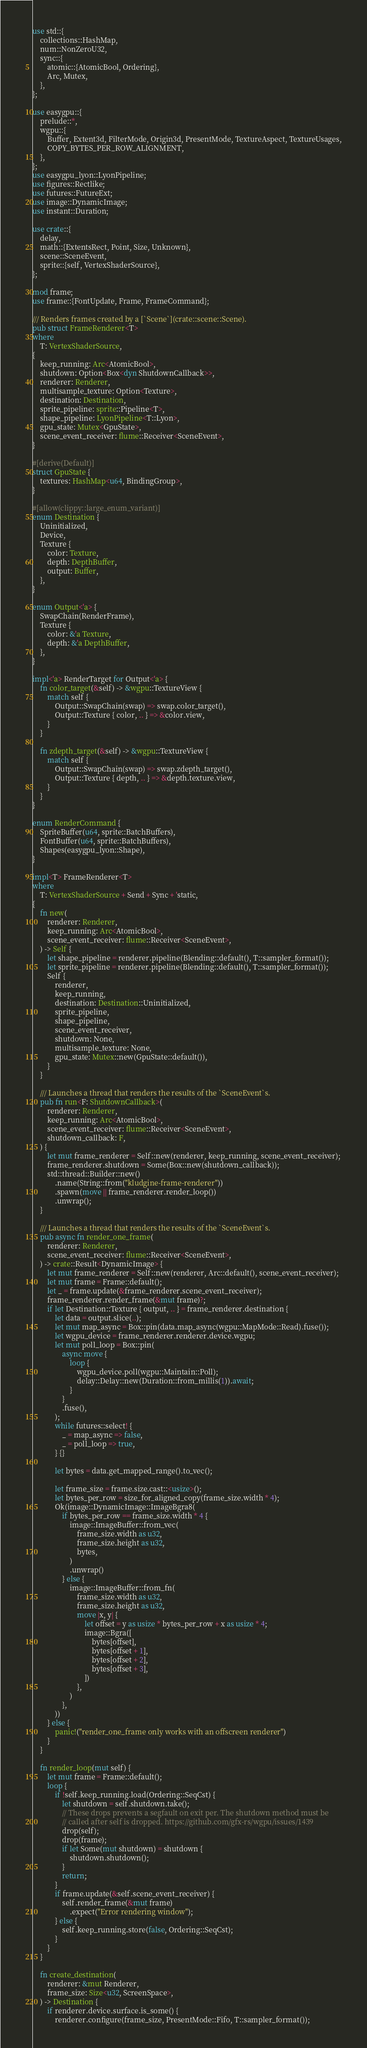<code> <loc_0><loc_0><loc_500><loc_500><_Rust_>use std::{
    collections::HashMap,
    num::NonZeroU32,
    sync::{
        atomic::{AtomicBool, Ordering},
        Arc, Mutex,
    },
};

use easygpu::{
    prelude::*,
    wgpu::{
        Buffer, Extent3d, FilterMode, Origin3d, PresentMode, TextureAspect, TextureUsages,
        COPY_BYTES_PER_ROW_ALIGNMENT,
    },
};
use easygpu_lyon::LyonPipeline;
use figures::Rectlike;
use futures::FutureExt;
use image::DynamicImage;
use instant::Duration;

use crate::{
    delay,
    math::{ExtentsRect, Point, Size, Unknown},
    scene::SceneEvent,
    sprite::{self, VertexShaderSource},
};

mod frame;
use frame::{FontUpdate, Frame, FrameCommand};

/// Renders frames created by a [`Scene`](crate::scene::Scene).
pub struct FrameRenderer<T>
where
    T: VertexShaderSource,
{
    keep_running: Arc<AtomicBool>,
    shutdown: Option<Box<dyn ShutdownCallback>>,
    renderer: Renderer,
    multisample_texture: Option<Texture>,
    destination: Destination,
    sprite_pipeline: sprite::Pipeline<T>,
    shape_pipeline: LyonPipeline<T::Lyon>,
    gpu_state: Mutex<GpuState>,
    scene_event_receiver: flume::Receiver<SceneEvent>,
}

#[derive(Default)]
struct GpuState {
    textures: HashMap<u64, BindingGroup>,
}

#[allow(clippy::large_enum_variant)]
enum Destination {
    Uninitialized,
    Device,
    Texture {
        color: Texture,
        depth: DepthBuffer,
        output: Buffer,
    },
}

enum Output<'a> {
    SwapChain(RenderFrame),
    Texture {
        color: &'a Texture,
        depth: &'a DepthBuffer,
    },
}

impl<'a> RenderTarget for Output<'a> {
    fn color_target(&self) -> &wgpu::TextureView {
        match self {
            Output::SwapChain(swap) => swap.color_target(),
            Output::Texture { color, .. } => &color.view,
        }
    }

    fn zdepth_target(&self) -> &wgpu::TextureView {
        match self {
            Output::SwapChain(swap) => swap.zdepth_target(),
            Output::Texture { depth, .. } => &depth.texture.view,
        }
    }
}

enum RenderCommand {
    SpriteBuffer(u64, sprite::BatchBuffers),
    FontBuffer(u64, sprite::BatchBuffers),
    Shapes(easygpu_lyon::Shape),
}

impl<T> FrameRenderer<T>
where
    T: VertexShaderSource + Send + Sync + 'static,
{
    fn new(
        renderer: Renderer,
        keep_running: Arc<AtomicBool>,
        scene_event_receiver: flume::Receiver<SceneEvent>,
    ) -> Self {
        let shape_pipeline = renderer.pipeline(Blending::default(), T::sampler_format());
        let sprite_pipeline = renderer.pipeline(Blending::default(), T::sampler_format());
        Self {
            renderer,
            keep_running,
            destination: Destination::Uninitialized,
            sprite_pipeline,
            shape_pipeline,
            scene_event_receiver,
            shutdown: None,
            multisample_texture: None,
            gpu_state: Mutex::new(GpuState::default()),
        }
    }

    /// Launches a thread that renders the results of the `SceneEvent`s.
    pub fn run<F: ShutdownCallback>(
        renderer: Renderer,
        keep_running: Arc<AtomicBool>,
        scene_event_receiver: flume::Receiver<SceneEvent>,
        shutdown_callback: F,
    ) {
        let mut frame_renderer = Self::new(renderer, keep_running, scene_event_receiver);
        frame_renderer.shutdown = Some(Box::new(shutdown_callback));
        std::thread::Builder::new()
            .name(String::from("kludgine-frame-renderer"))
            .spawn(move || frame_renderer.render_loop())
            .unwrap();
    }

    /// Launches a thread that renders the results of the `SceneEvent`s.
    pub async fn render_one_frame(
        renderer: Renderer,
        scene_event_receiver: flume::Receiver<SceneEvent>,
    ) -> crate::Result<DynamicImage> {
        let mut frame_renderer = Self::new(renderer, Arc::default(), scene_event_receiver);
        let mut frame = Frame::default();
        let _ = frame.update(&frame_renderer.scene_event_receiver);
        frame_renderer.render_frame(&mut frame)?;
        if let Destination::Texture { output, .. } = frame_renderer.destination {
            let data = output.slice(..);
            let mut map_async = Box::pin(data.map_async(wgpu::MapMode::Read).fuse());
            let wgpu_device = frame_renderer.renderer.device.wgpu;
            let mut poll_loop = Box::pin(
                async move {
                    loop {
                        wgpu_device.poll(wgpu::Maintain::Poll);
                        delay::Delay::new(Duration::from_millis(1)).await;
                    }
                }
                .fuse(),
            );
            while futures::select! {
                _ = map_async => false,
                _ = poll_loop => true,
            } {}

            let bytes = data.get_mapped_range().to_vec();

            let frame_size = frame.size.cast::<usize>();
            let bytes_per_row = size_for_aligned_copy(frame_size.width * 4);
            Ok(image::DynamicImage::ImageBgra8(
                if bytes_per_row == frame_size.width * 4 {
                    image::ImageBuffer::from_vec(
                        frame_size.width as u32,
                        frame_size.height as u32,
                        bytes,
                    )
                    .unwrap()
                } else {
                    image::ImageBuffer::from_fn(
                        frame_size.width as u32,
                        frame_size.height as u32,
                        move |x, y| {
                            let offset = y as usize * bytes_per_row + x as usize * 4;
                            image::Bgra([
                                bytes[offset],
                                bytes[offset + 1],
                                bytes[offset + 2],
                                bytes[offset + 3],
                            ])
                        },
                    )
                },
            ))
        } else {
            panic!("render_one_frame only works with an offscreen renderer")
        }
    }

    fn render_loop(mut self) {
        let mut frame = Frame::default();
        loop {
            if !self.keep_running.load(Ordering::SeqCst) {
                let shutdown = self.shutdown.take();
                // These drops prevents a segfault on exit per. The shutdown method must be
                // called after self is dropped. https://github.com/gfx-rs/wgpu/issues/1439
                drop(self);
                drop(frame);
                if let Some(mut shutdown) = shutdown {
                    shutdown.shutdown();
                }
                return;
            }
            if frame.update(&self.scene_event_receiver) {
                self.render_frame(&mut frame)
                    .expect("Error rendering window");
            } else {
                self.keep_running.store(false, Ordering::SeqCst);
            }
        }
    }

    fn create_destination(
        renderer: &mut Renderer,
        frame_size: Size<u32, ScreenSpace>,
    ) -> Destination {
        if renderer.device.surface.is_some() {
            renderer.configure(frame_size, PresentMode::Fifo, T::sampler_format());</code> 